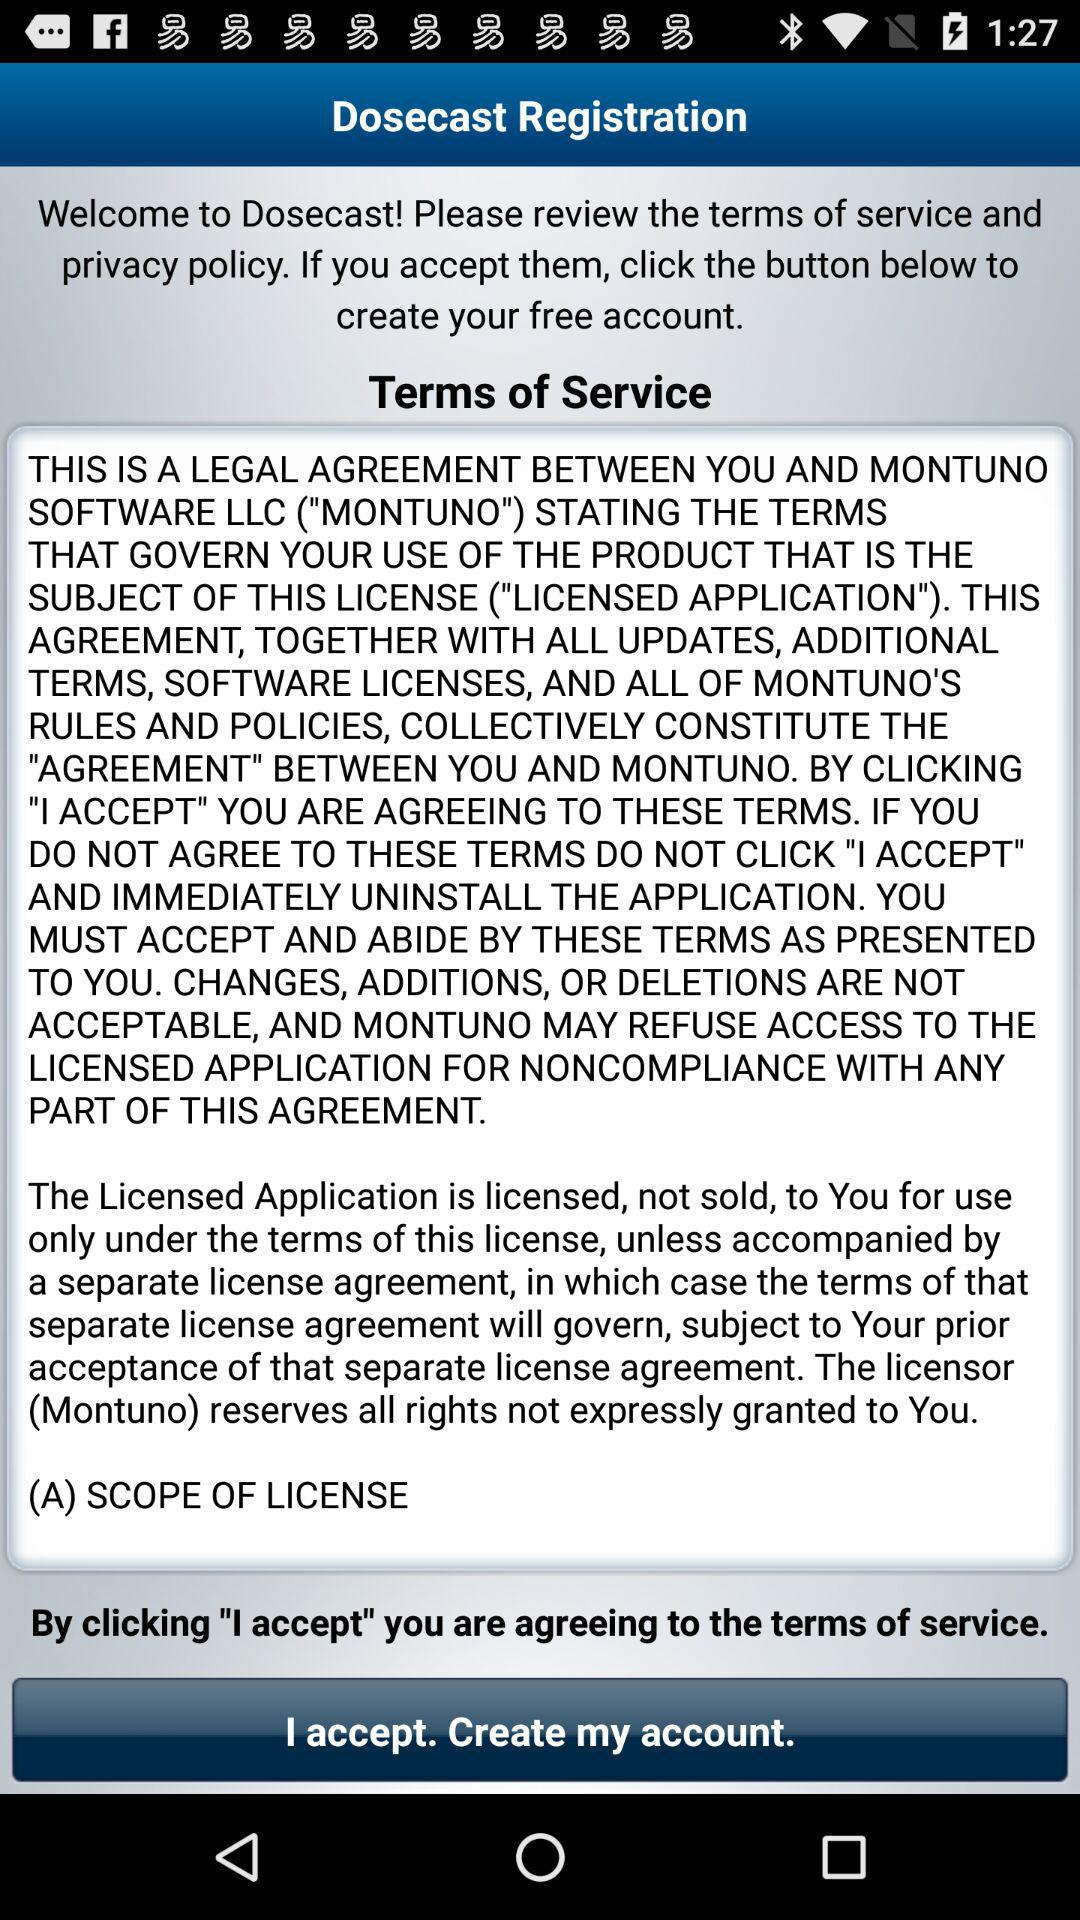What are the terms of service? The terms of service are "THIS IS A LEGAL AGREEMENT BETWEEN YOU AND MONTUNO SOFTWARE LLC ("MONTUNO") STATING THE TERMS THAT GOVERN YOUR USE OF THE PRODUCT THAT IS THE SUBJECT OF THIS LICENSE ("LICENSED APPLICATION"). THIS AGREEMENT, TOGETHER WITH ALL UPDATES, ADDITIONAL TERMS, SOFTWARE LICENSES, AND ALL OF MONTUNO'S RULES AND POLICIES, COLLECTIVELY CONSTITUTE THE "AGREEMENT BETWEEN YOU AND MONTUNO. BY CLICKING I ACCEPT YOU ARE AGREEING TO THESE TERMS. IF YOU DO NOT AGREE TO THESE TERMS DO NOT CLICK "I ACCEPT" AND IMMEDIATELY UNINSTALL THE APPLICATION YOU MUST ACCEPT AND ABIDE BY THESE TERMS AS PRESENTED TO YOU. CHANGES, ADDITIONS, OR DELETIONS ARE NOT ACCEPTABLE, AND MONTUNO MAY REFUSE ACCESS TO THE LICENSED APPLICATION FOR NONCOMPLIANCE WITH ANY PART OF THIS AGREEMENT. The Licensed Application is licensed, not sold, to You for use only under the terms of this license, unless accompanied by a separate license agreement, in which case the terms of that separate license agreement will govern, subject to Your prior acceptance of that separate license agreement. The licensor (Montuno) reserves all rights not expressly granted to You. (A) SCOPE OF LICENCE". 